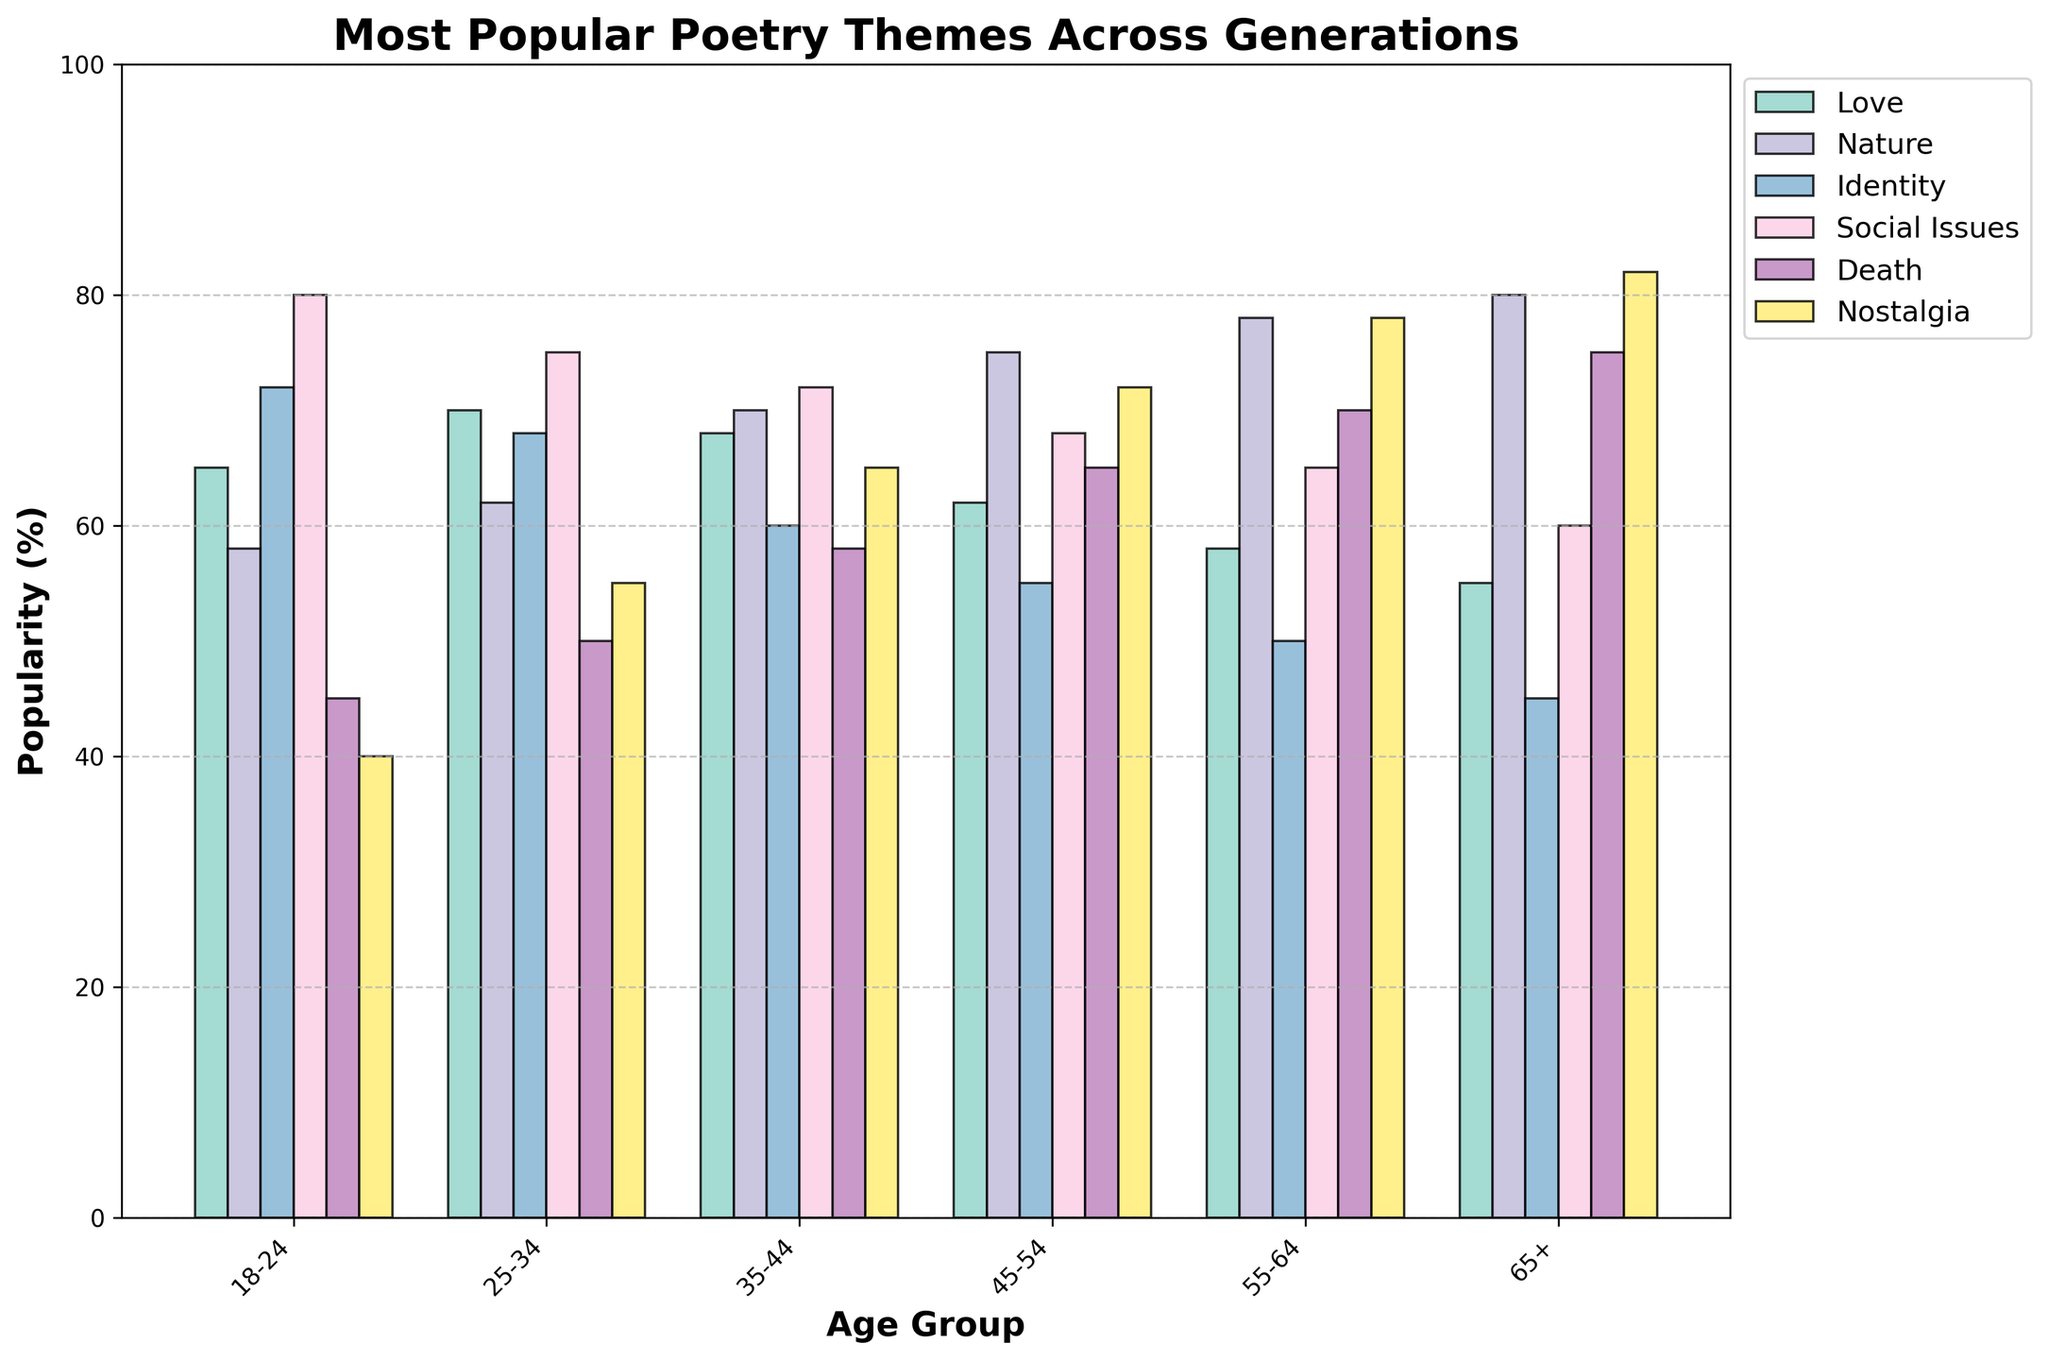What's the most popular theme for the 18-24 age group? Look at the bar corresponding to the 18-24 age group. The tallest bar indicates the most popular theme, which is "Social Issues" with 80%.
Answer: Social Issues Which age group values Nostalgia the most? Check the height of the bars representing Nostalgia for each age group. The tallest bar is for the 65+ age group at 82%.
Answer: 65+ What is the average popularity of the Love theme across all age groups? Sum the percentages of the Love theme for all age groups (65 + 70 + 68 + 62 + 58 + 55) and divide by the number of age groups (6). Calculation is (65 + 70 + 68 + 62 + 58 + 55) / 6 = 378 / 6 = 63.
Answer: 63 Which age group shows a greater preference for Death, 18-24 or 25-34? Compare the heights of the Death bars for the 18-24 (45%) and 25-34 (50%) age groups. The 25-34 group has a higher value.
Answer: 25-34 What's the least popular theme for the 35-44 age group? Look at the lowest bar in the 35-44 age group, which is "Identity" at 60%.
Answer: Identity How much more popular is the Nature theme in the 55-64 age group compared to the 18-24 age group? Subtract the Nature percentage of the 18-24 age group (58%) from the 55-64 age group (78%). Calculation is 78 - 58 = 20.
Answer: 20 In which theme does the 45-54 age group score higher than the 25-34 age group? Compare the bars for these age groups across all themes. 45-54 age group scores higher in Nature (75% vs 62%), Death (65% vs 50%), and Nostalgia (72% vs 55%).
Answer: Nature, Death, Nostalgia What's the difference in popularity of the Social Issues theme between the youngest (18-24) and the oldest (65+) age groups? Subtract the Social Issues percentage of the 65+ age group (60%) from the 18-24 age group (80%). Calculation is 80 - 60 = 20.
Answer: 20 What is the overall trend in popularity for the Nostalgia theme as the age group increases? Examine the bars for Nostalgia across age groups. The trend shows a steady increase from 40% in 18-24 to 82% in 65+.
Answer: Increasing Which age group has the highest variability in themes? Assess the range of bar heights (difference between highest and lowest percentages) for each age group. Greater range indicates higher variability. The 18-24 age group's range is highest (40-80 = 40%).
Answer: 18-24 